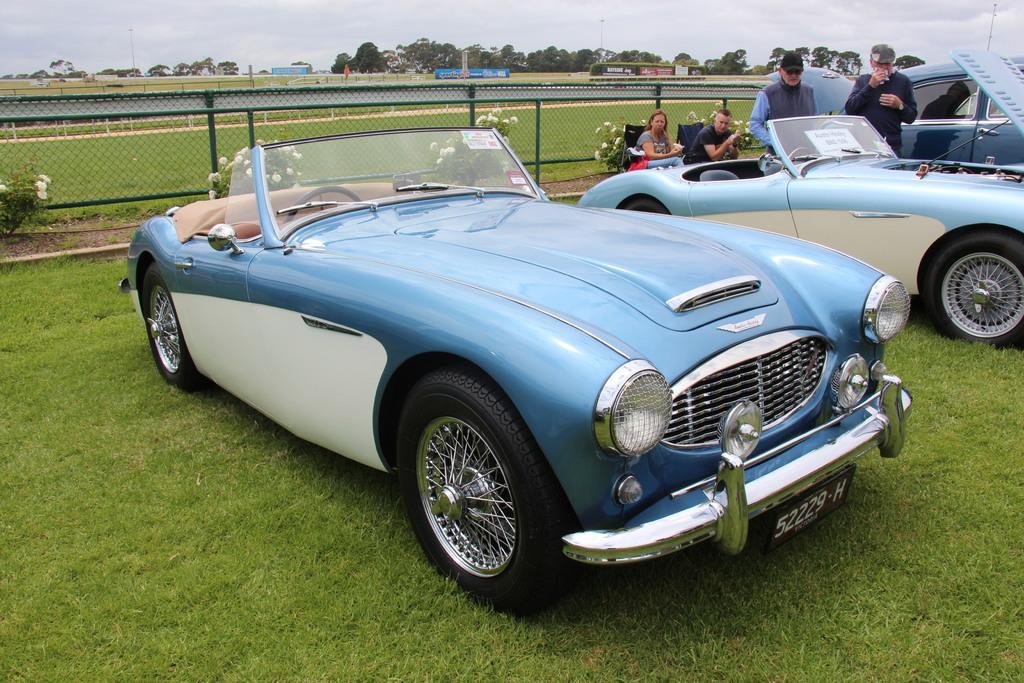In one or two sentences, can you explain what this image depicts? In the center of the image there are cars. On the left there are people standing. In the background we can see people sitting. On the chairs there is a fence. We can see trees, boards and sky. 